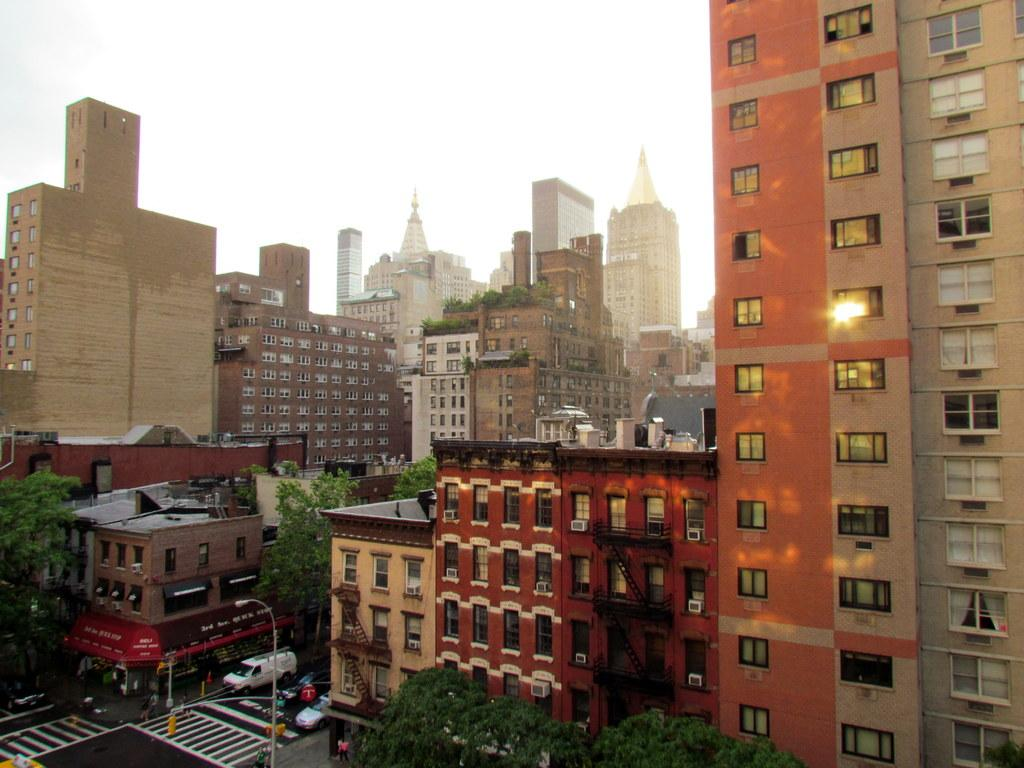What type of structures are present in the image? There are many buildings in the image. What feature do the buildings have in common? The buildings have windows. What is located at the bottom of the image? There is a road at the bottom of the image. What type of vegetation can be seen in the image? There are trees visible in the image. What is visible at the top of the image? The sky is visible at the top of the image. Can you tell me how many times the bit has crushed the spring in the image? There is no bit or spring present in the image; it features buildings, a road, trees, and the sky. 